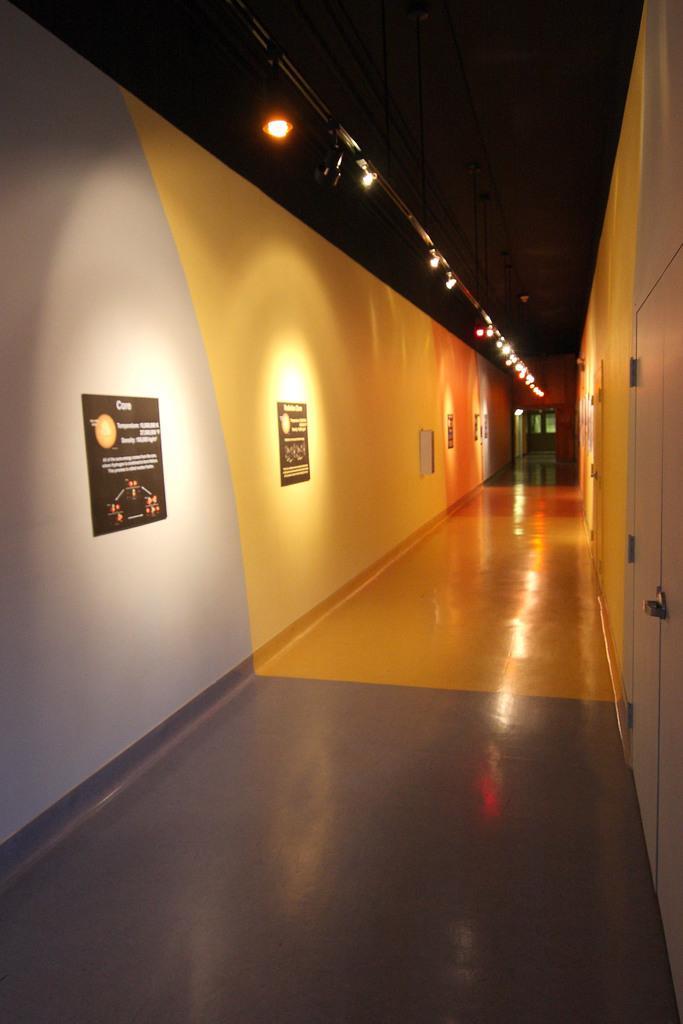Could you give a brief overview of what you see in this image? In this image on the left side there are posters on the wall with some text written on it. On the right side there is a door which is white in colour. At the top there are lights. 